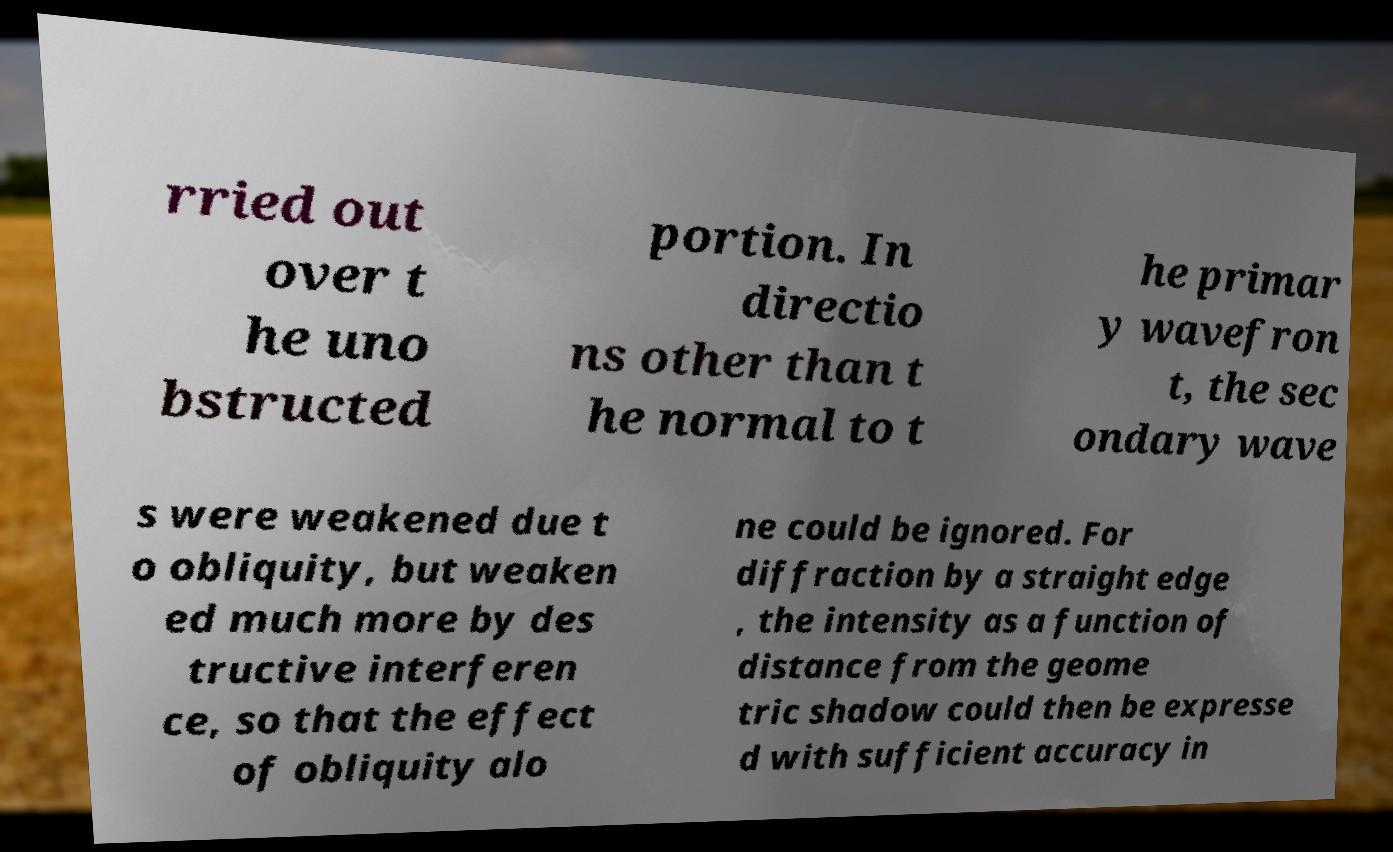Please identify and transcribe the text found in this image. rried out over t he uno bstructed portion. In directio ns other than t he normal to t he primar y wavefron t, the sec ondary wave s were weakened due t o obliquity, but weaken ed much more by des tructive interferen ce, so that the effect of obliquity alo ne could be ignored. For diffraction by a straight edge , the intensity as a function of distance from the geome tric shadow could then be expresse d with sufficient accuracy in 